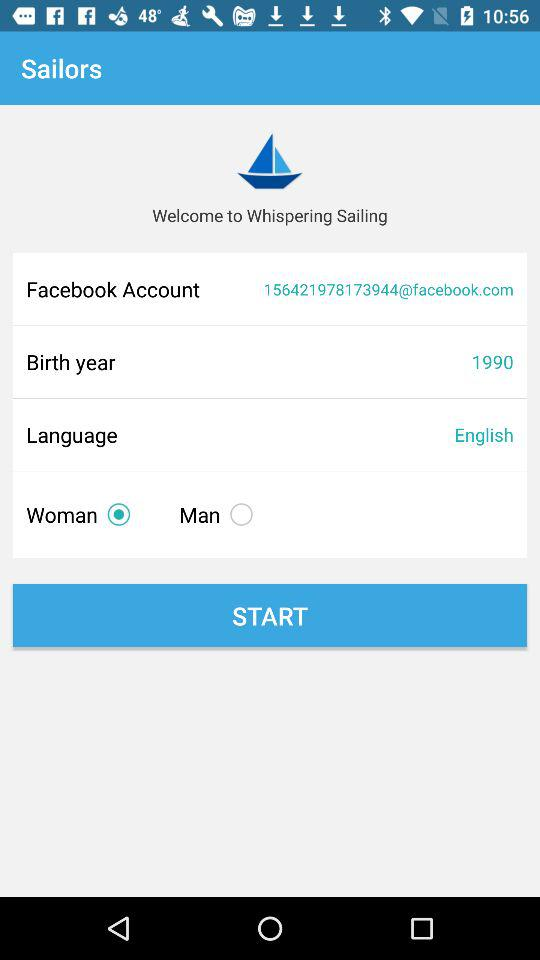Which language is mentioned? The mentioned language is English. 